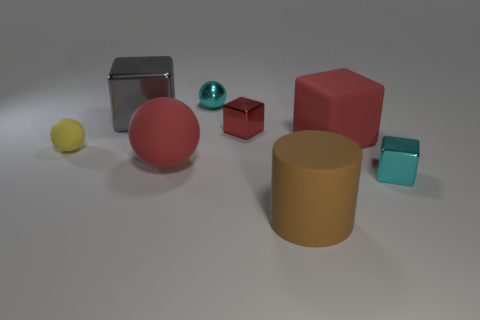Subtract 1 cubes. How many cubes are left? 3 Add 2 blue rubber cylinders. How many objects exist? 10 Subtract all cylinders. How many objects are left? 7 Add 3 tiny blue balls. How many tiny blue balls exist? 3 Subtract 0 blue cylinders. How many objects are left? 8 Subtract all yellow spheres. Subtract all yellow rubber things. How many objects are left? 6 Add 8 tiny rubber balls. How many tiny rubber balls are left? 9 